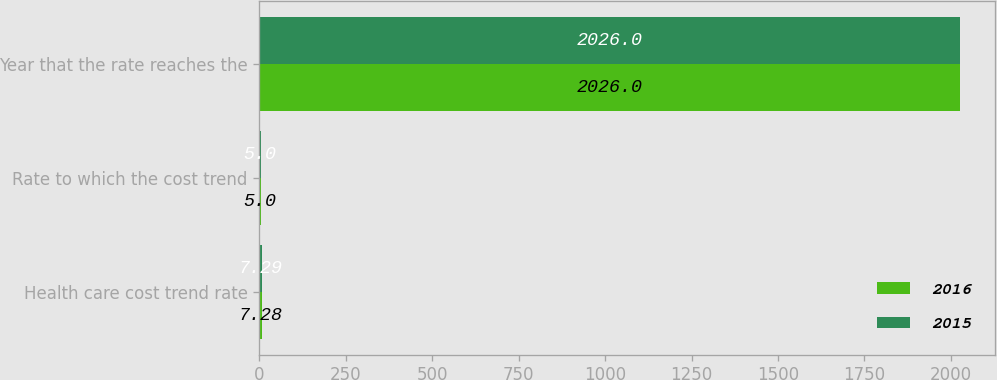Convert chart to OTSL. <chart><loc_0><loc_0><loc_500><loc_500><stacked_bar_chart><ecel><fcel>Health care cost trend rate<fcel>Rate to which the cost trend<fcel>Year that the rate reaches the<nl><fcel>2016<fcel>7.28<fcel>5<fcel>2026<nl><fcel>2015<fcel>7.29<fcel>5<fcel>2026<nl></chart> 